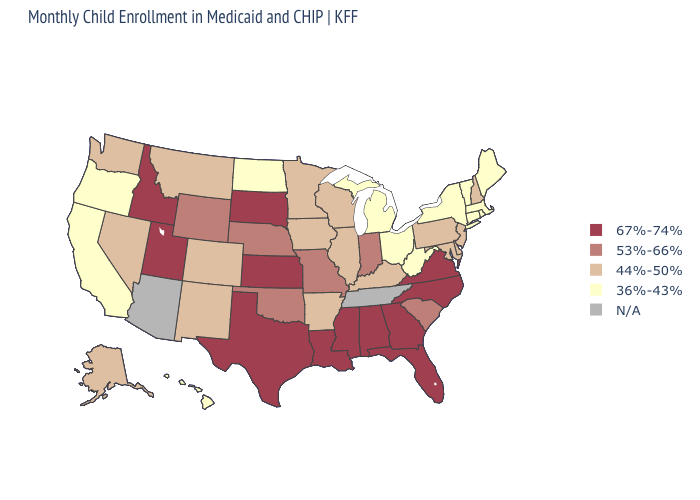Which states have the lowest value in the USA?
Quick response, please. California, Connecticut, Hawaii, Maine, Massachusetts, Michigan, New York, North Dakota, Ohio, Oregon, Rhode Island, Vermont, West Virginia. What is the value of North Dakota?
Write a very short answer. 36%-43%. What is the value of New Mexico?
Short answer required. 44%-50%. What is the highest value in the USA?
Answer briefly. 67%-74%. Among the states that border Iowa , does Wisconsin have the lowest value?
Be succinct. Yes. Which states hav the highest value in the South?
Write a very short answer. Alabama, Florida, Georgia, Louisiana, Mississippi, North Carolina, Texas, Virginia. What is the lowest value in the USA?
Quick response, please. 36%-43%. Which states have the lowest value in the West?
Concise answer only. California, Hawaii, Oregon. Name the states that have a value in the range 44%-50%?
Quick response, please. Alaska, Arkansas, Colorado, Delaware, Illinois, Iowa, Kentucky, Maryland, Minnesota, Montana, Nevada, New Hampshire, New Jersey, New Mexico, Pennsylvania, Washington, Wisconsin. Does the first symbol in the legend represent the smallest category?
Short answer required. No. Does Massachusetts have the highest value in the Northeast?
Keep it brief. No. Does Kansas have the highest value in the USA?
Give a very brief answer. Yes. What is the lowest value in the USA?
Write a very short answer. 36%-43%. What is the value of South Dakota?
Write a very short answer. 67%-74%. 